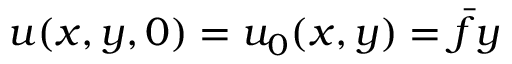Convert formula to latex. <formula><loc_0><loc_0><loc_500><loc_500>u ( x , y , 0 ) = u _ { 0 } ( x , y ) = \bar { f } y</formula> 